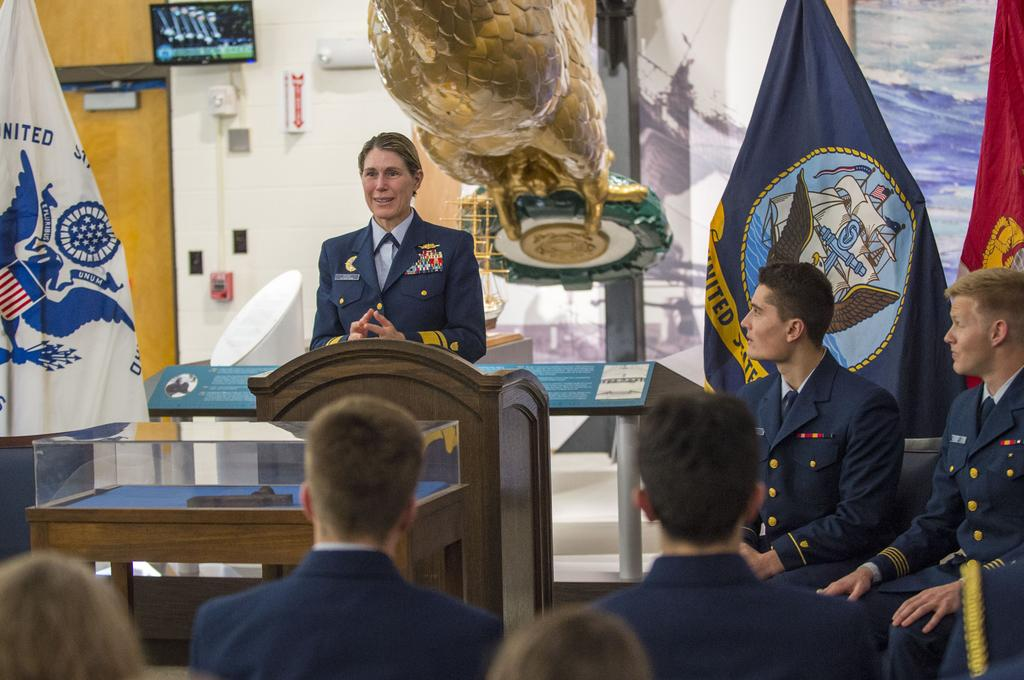How many people can be seen in the image? There are many people in the image. What can be seen in the background of the image? There are flags visible in the background of the image. Where is the TV located in the image? The TV is on the wall in the image. What is the opinion of the roof in the image? There is no roof present in the image, so it is not possible to determine its opinion. 